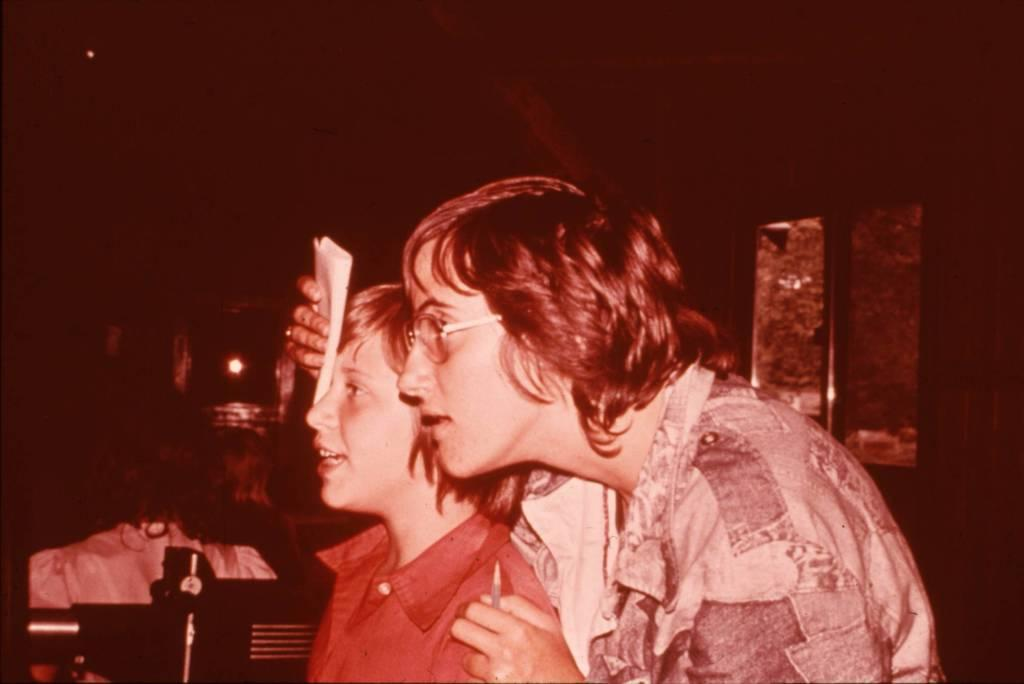How many people are in the room? There are 2 people in the room. What direction are the people facing? The people are facing towards the left. What can be observed about the person on the right? The person at the right is wearing spectacles and holding a pen and paper in his hands. What feature of the room is mentioned in the facts? There is a window in the room. What type of discovery was made by the person at the left in the image? There is no mention of a discovery in the image or the provided facts. --- Facts: 1. There is a car in the image. 2. The car is red. 3. The car has four wheels. 4. The car has a license plate. 5. The car is parked on the street. Absurd Topics: parrot, ocean, dance Conversation: What is the main subject of the image? The main subject of the image is a car. What color is the car? The car is red. How many wheels does the car have? The car has four wheels. What can be seen on the car to identify it? The car has a license plate. Where is the car located in the image? The car is parked on the street. Reasoning: Let's think step by step in order to produce the conversation. We start by identifying the main subject of the image, which is the car. Then, we describe the car's color, number of wheels, and the presence of a license plate. Finally, we mention the car's location, which is parked on the street. Absurd Question/Answer: Can you tell me how many parrots are sitting on the car in the image? There are no parrots present in the image; it features a red car with four wheels and a license plate. --- Facts: 1. There is a group of people in the image. 2. The people are wearing hats. 3. The people are holding hands. 4. The background of the image is a park. 5. There are trees in the park. Absurd Topics: elephant, rain, mountain Conversation: How many people are in the image? There is a group of people in the image. What are the people wearing? The people are wearing hats. What are the people doing in the image? The people are holding hands. What can be seen in the background of the image? The background of the image is a park. What type of vegetation is present in the park? There are trees in the park. Reasoning: Let's think step by step in order to produce the conversation. We start by identifying the main subject of the image, which is a group of people. Then, we describe what the people are 